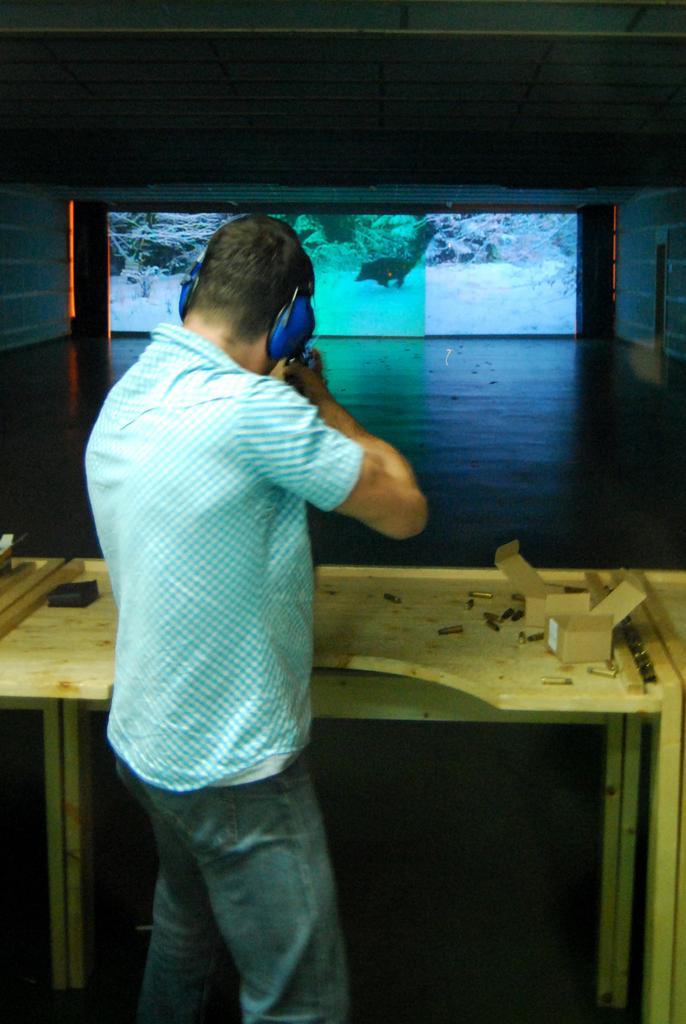Describe this image in one or two sentences. In this image there is a person holding some object. In front of him there is a table. On top of it there are bullets and there are a few other objects. In the background of the image there is a screen. There are lights. There is a wall. At the bottom of the image there is a floor. 